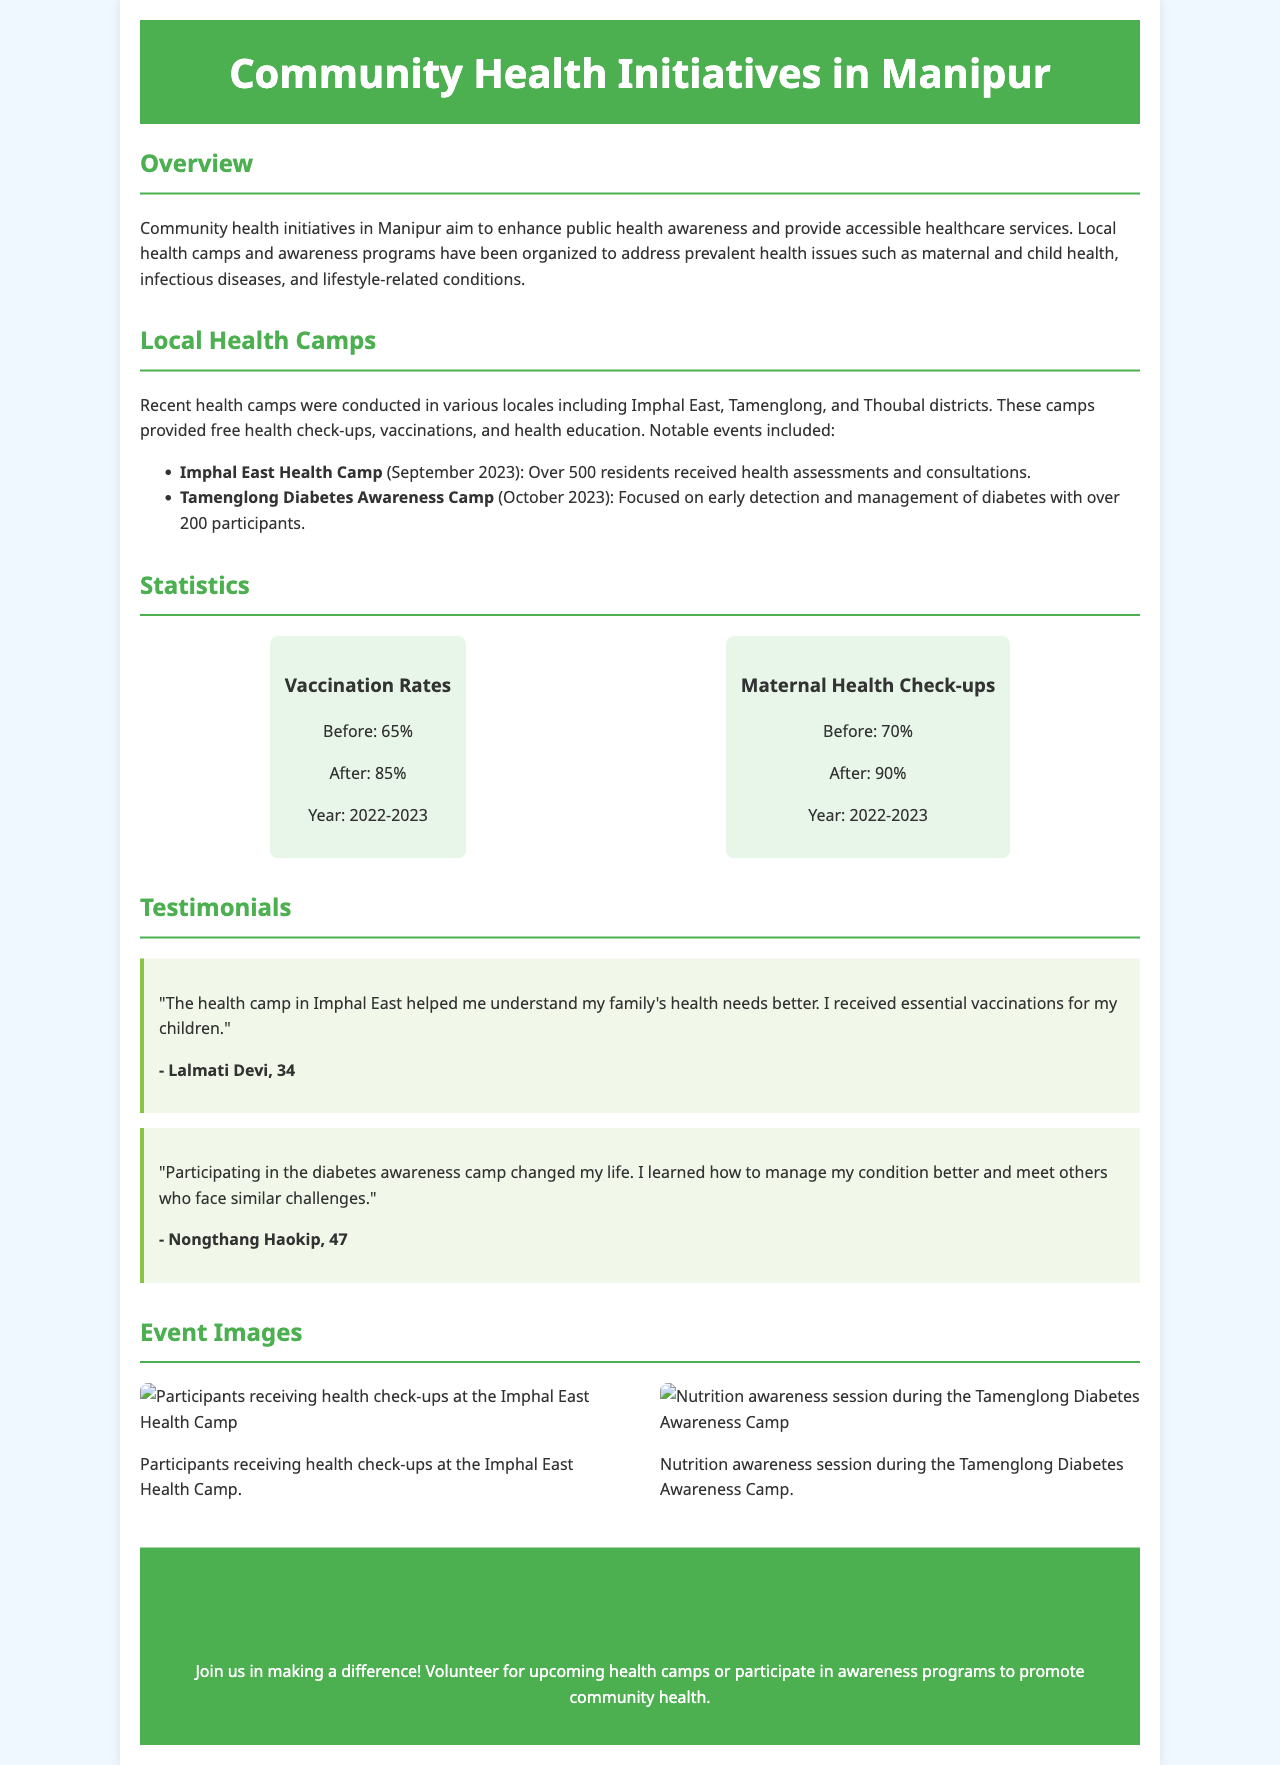What is the title of the brochure? The title states the focus of the document as an overview of health initiatives in the region.
Answer: Community Health Initiatives in Manipur What health camp was held in September 2023? The document mentions a specific event date and location for a health camp.
Answer: Imphal East Health Camp How many residents received health assessments at the Imphal East Health Camp? A specific number is provided in the document for the residents served during the health camp.
Answer: Over 500 What percentage of maternal health check-ups was achieved after the initiative? The document provides before and after statistics regarding maternal health check-ups.
Answer: 90% What was the focus of the Tamenglong Diabetes Awareness Camp? The document outlines the primary aim of this particular health initiative.
Answer: Early detection and management of diabetes Who provided a testimonial about the health camp in Imphal East? The brochure includes names of individuals providing testimonials related to the health initiatives.
Answer: Lalmati Devi What type of awareness session was conducted during the Tamenglong Diabetes Awareness Camp? The document specifies the nature of educational activities that took place during the camp.
Answer: Nutrition awareness session In which districts were recent health camps conducted? The document lists the locations for the health camps, which includes multiple areas.
Answer: Imphal East, Tamenglong, Thoubal How many participants attended the diabetes awareness camp? A specific attendance number is given in the document regarding the diabetes awareness camp.
Answer: Over 200 